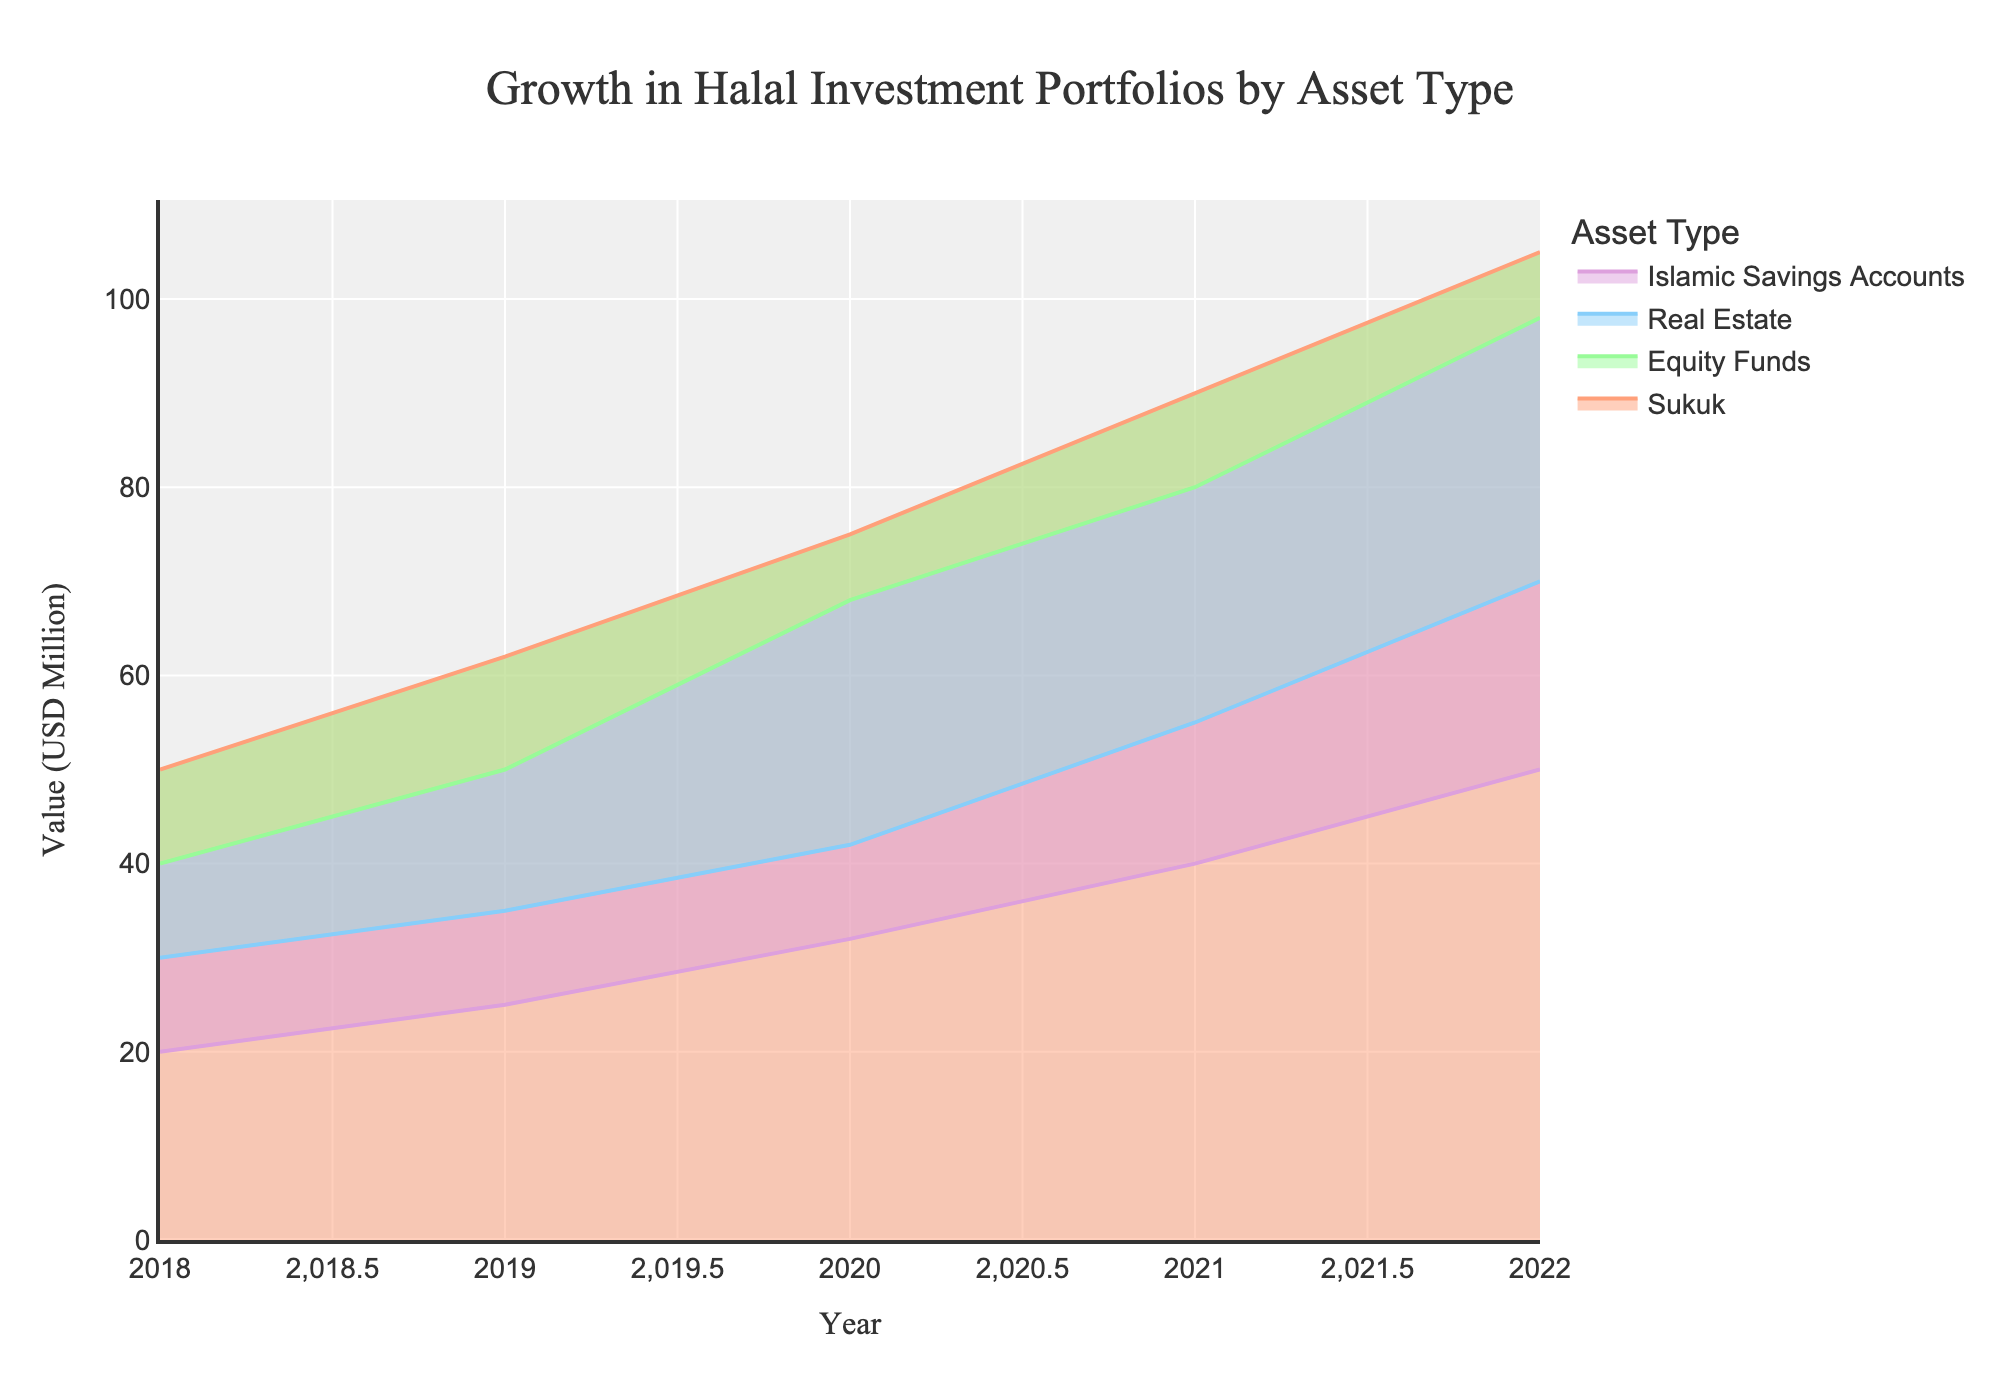What is the title of the chart? The title is typically located at the top of the chart and is clearly written. In this case, the title is "Growth in Halal Investment Portfolios by Asset Type".
Answer: Growth in Halal Investment Portfolios by Asset Type Which asset type had the highest value in 2022? By examining the chart and looking at the values for each asset type in the year 2022, one can see that "Sukuk" has the highest value.
Answer: Sukuk How did the value of Sukuk change from 2018 to 2022? To determine the change, check the values for Sukuk in 2018 and 2022, then find the difference: 105 - 50 = 55.
Answer: Increased by 55 million USD What was the value of Real Estate in 2020? Find the point on the chart corresponding to Real Estate for the year 2020. The value is clearly marked.
Answer: 42 million USD Which asset type showed the most consistent growth over the years? By observing the trends and slopes of the lines in the chart, "Islamic Savings Accounts" shows a steady and consistent increase without significant deviation.
Answer: Islamic Savings Accounts What is the combined value of Equity Funds and Real Estate in 2021? Locate the values for both Equity Funds and Real Estate in 2021 and sum them: 80 (Equity Funds) + 55 (Real Estate) = 135.
Answer: 135 million USD Which year showed the highest increase in value for Sukuk compared to the previous year? Calculate the yearly increase for Sukuk and compare: From 2018 to 2019: 12, 2019 to 2020: 13, 2020 to 2021: 15, 2021 to 2022: 15. Both 2020 to 2021 and 2021 to 2022 have the highest increase of 15 million USD.
Answer: 2020 to 2021 or 2021 to 2022 How does the growth trend of Islamic Savings Accounts compare to that of Sukuk? Both trends show a consistent upward growth, but Sukuk started with higher values and maintained a faster-growing trend. Meanwhile, Islamic Savings Accounts show steady but slower growth.
Answer: Sukuk grew faster What is the average annual growth rate for Real Estate from 2018 to 2022? First, calculate the total increase: 70 - 30 = 40. Then divide by the number of years-1 (since it's a step area chart, there will be 4 steps): 40/4 = 10 million USD per year.
Answer: 10 million USD per year 